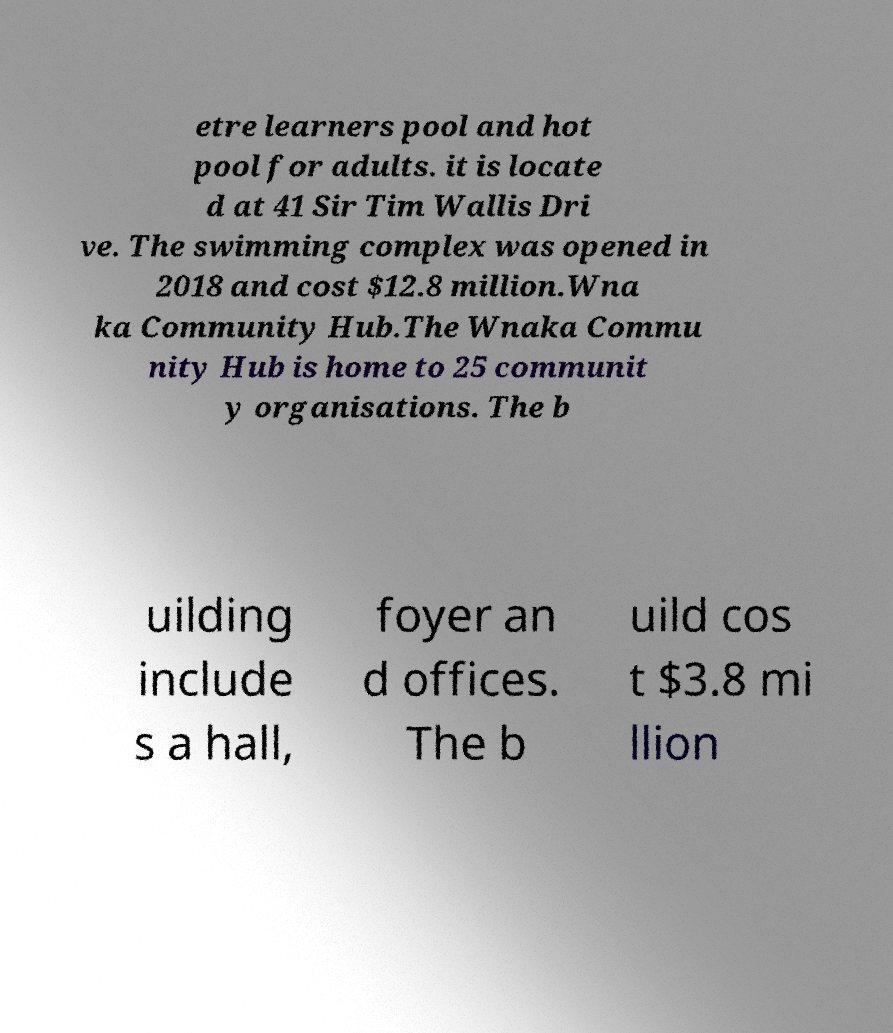I need the written content from this picture converted into text. Can you do that? etre learners pool and hot pool for adults. it is locate d at 41 Sir Tim Wallis Dri ve. The swimming complex was opened in 2018 and cost $12.8 million.Wna ka Community Hub.The Wnaka Commu nity Hub is home to 25 communit y organisations. The b uilding include s a hall, foyer an d offices. The b uild cos t $3.8 mi llion 